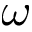Convert formula to latex. <formula><loc_0><loc_0><loc_500><loc_500>\omega</formula> 